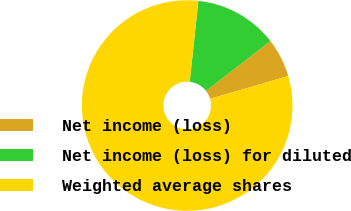Convert chart. <chart><loc_0><loc_0><loc_500><loc_500><pie_chart><fcel>Net income (loss)<fcel>Net income (loss) for diluted<fcel>Weighted average shares<nl><fcel>5.97%<fcel>12.81%<fcel>81.21%<nl></chart> 